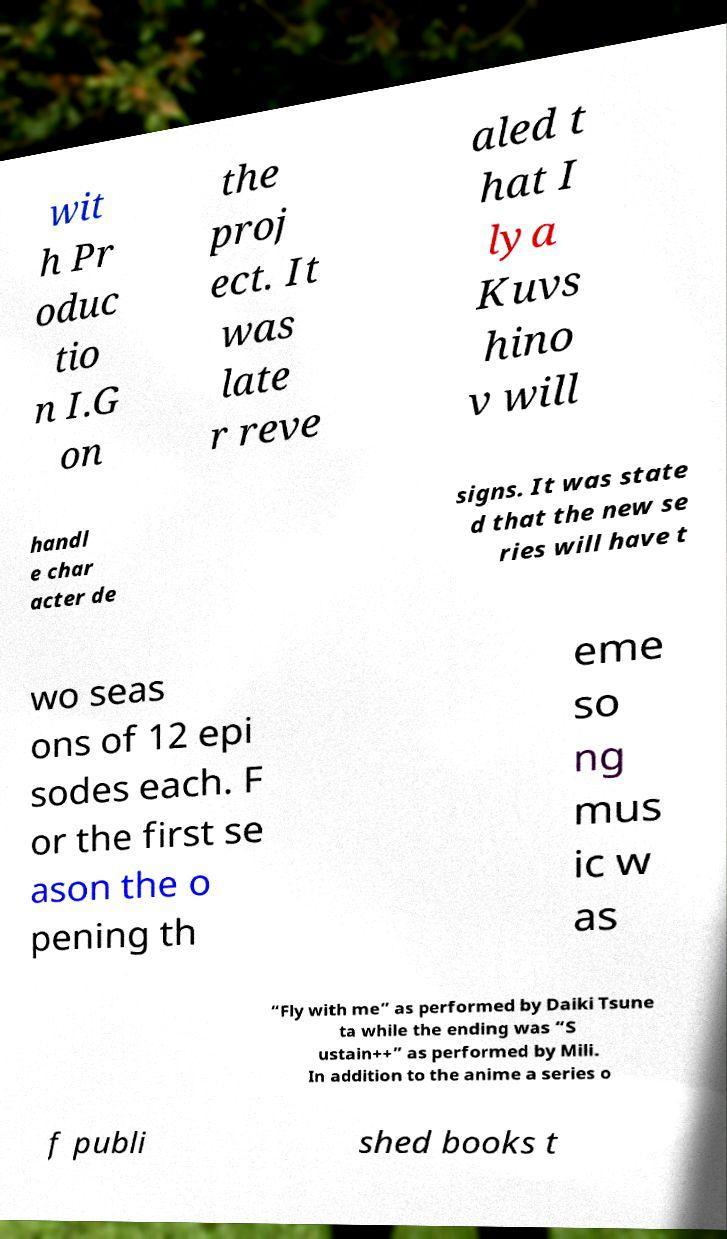Can you read and provide the text displayed in the image?This photo seems to have some interesting text. Can you extract and type it out for me? wit h Pr oduc tio n I.G on the proj ect. It was late r reve aled t hat I lya Kuvs hino v will handl e char acter de signs. It was state d that the new se ries will have t wo seas ons of 12 epi sodes each. F or the first se ason the o pening th eme so ng mus ic w as “Fly with me” as performed by Daiki Tsune ta while the ending was “S ustain++” as performed by Mili. In addition to the anime a series o f publi shed books t 